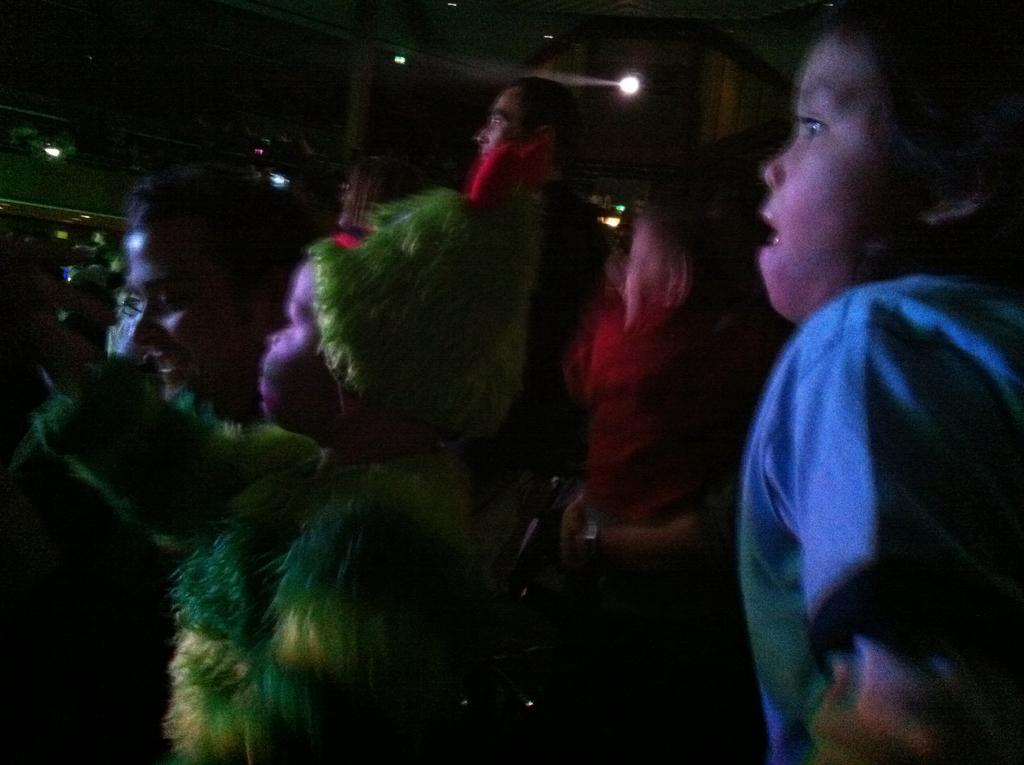How many people are in the image? There are persons in the image, but the exact number is not specified. What is unique about the appearance of one person in the image? One person is dressed up with a costume. What can be seen at the top of the image? There are lights visible at the top of the image. Can you see a balloon being inflated by the person in the costume? There is no mention of a balloon in the image, so it cannot be confirmed whether it is being inflated or not. 